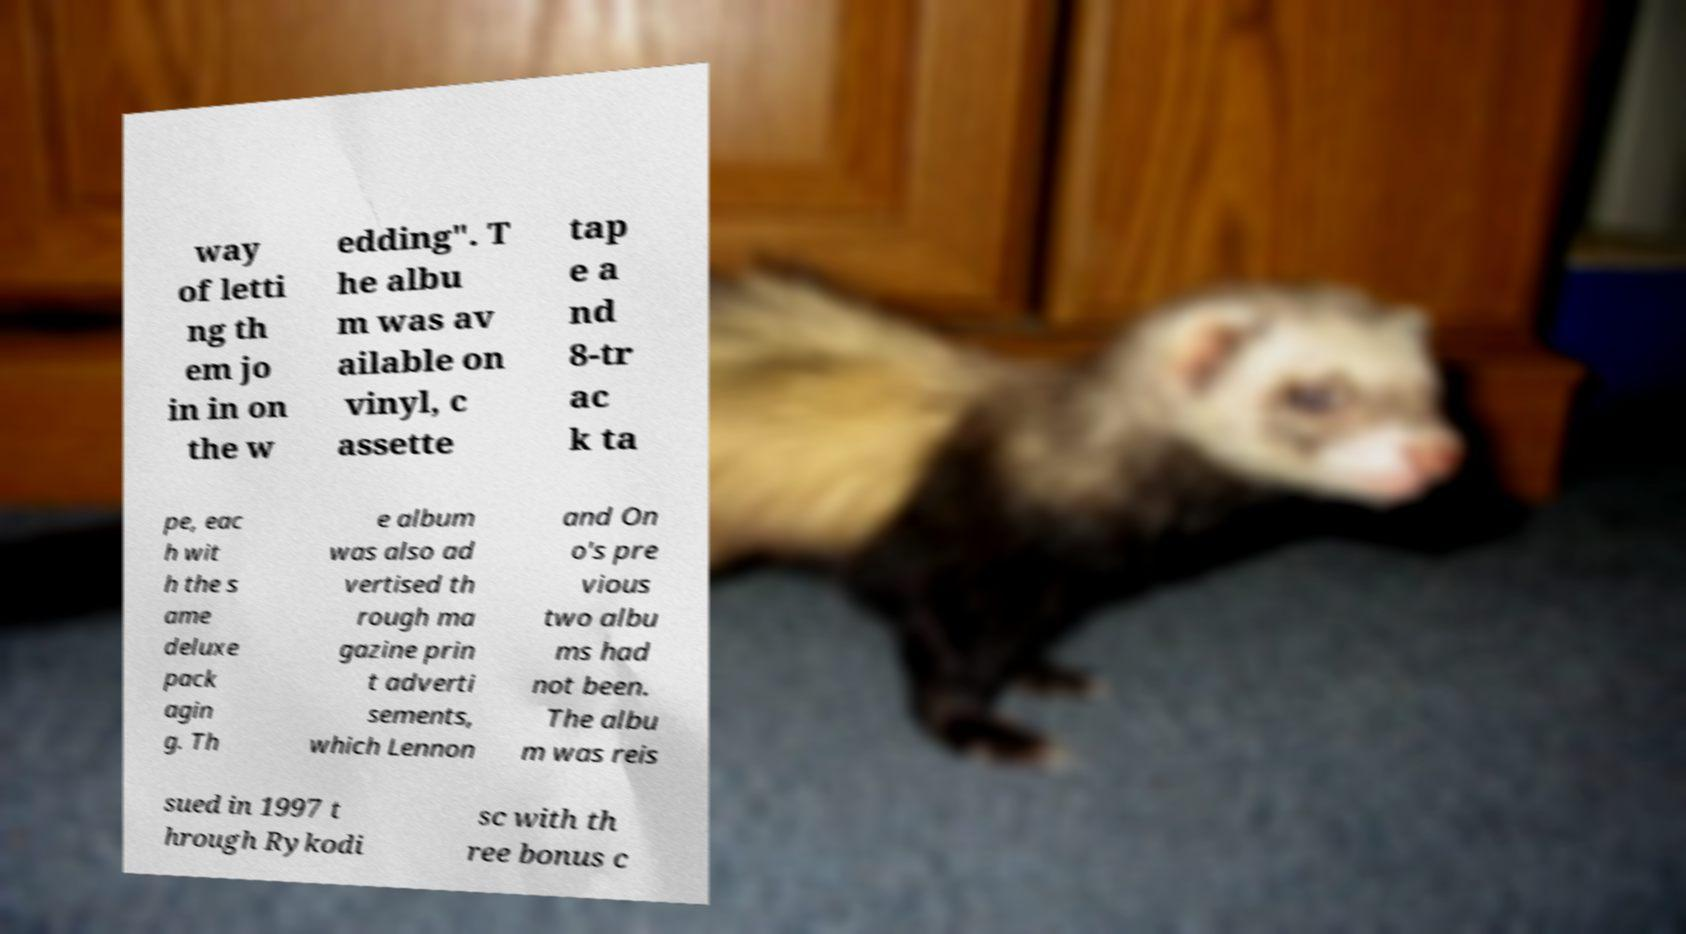Can you read and provide the text displayed in the image?This photo seems to have some interesting text. Can you extract and type it out for me? way of letti ng th em jo in in on the w edding". T he albu m was av ailable on vinyl, c assette tap e a nd 8-tr ac k ta pe, eac h wit h the s ame deluxe pack agin g. Th e album was also ad vertised th rough ma gazine prin t adverti sements, which Lennon and On o's pre vious two albu ms had not been. The albu m was reis sued in 1997 t hrough Rykodi sc with th ree bonus c 